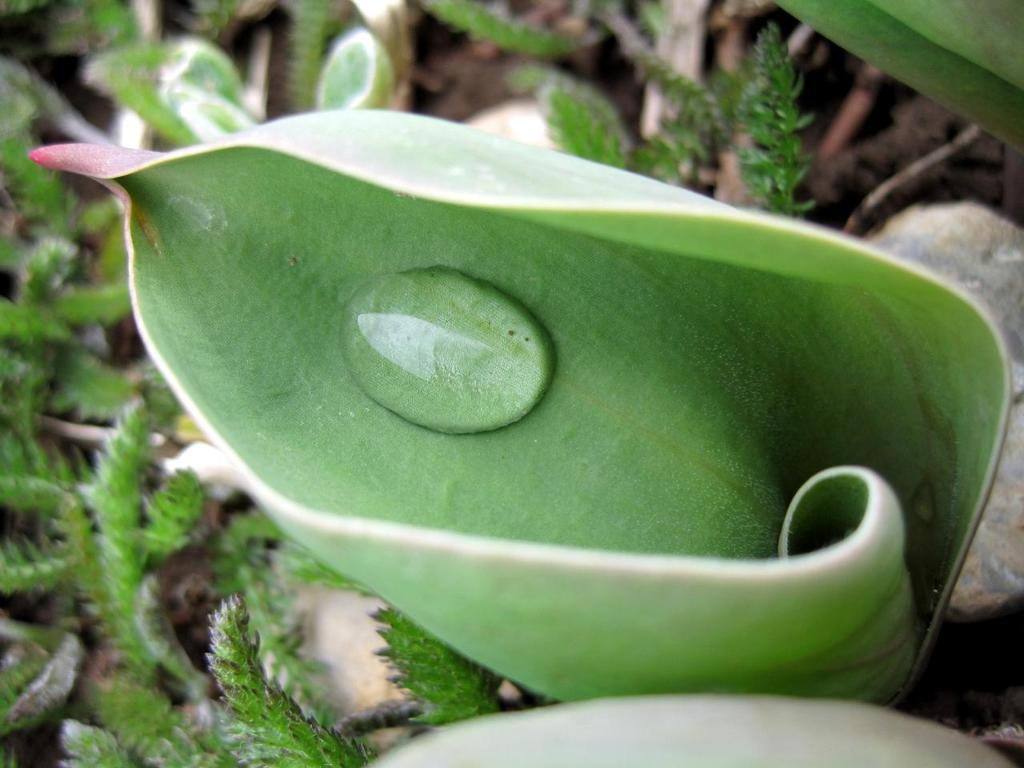What is the main subject in the center of the image? There is a leaf in the center of the image. What is on the leaf? There is a water drop on the leaf. What can be seen in the background of the image? There are plants in the background of the image. How far away is the hydrant from the leaf in the image? There is no hydrant present in the image, so it cannot be determined how far away it might be from the leaf. 